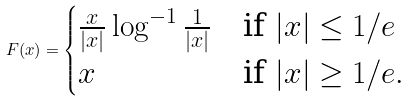<formula> <loc_0><loc_0><loc_500><loc_500>F ( x ) = \begin{cases} \frac { x } { | x | } \log ^ { - 1 } \frac { 1 } { | x | } & \text {if } | x | \leq 1 / e \\ x & \text {if } | x | \geq 1 / e . \end{cases}</formula> 